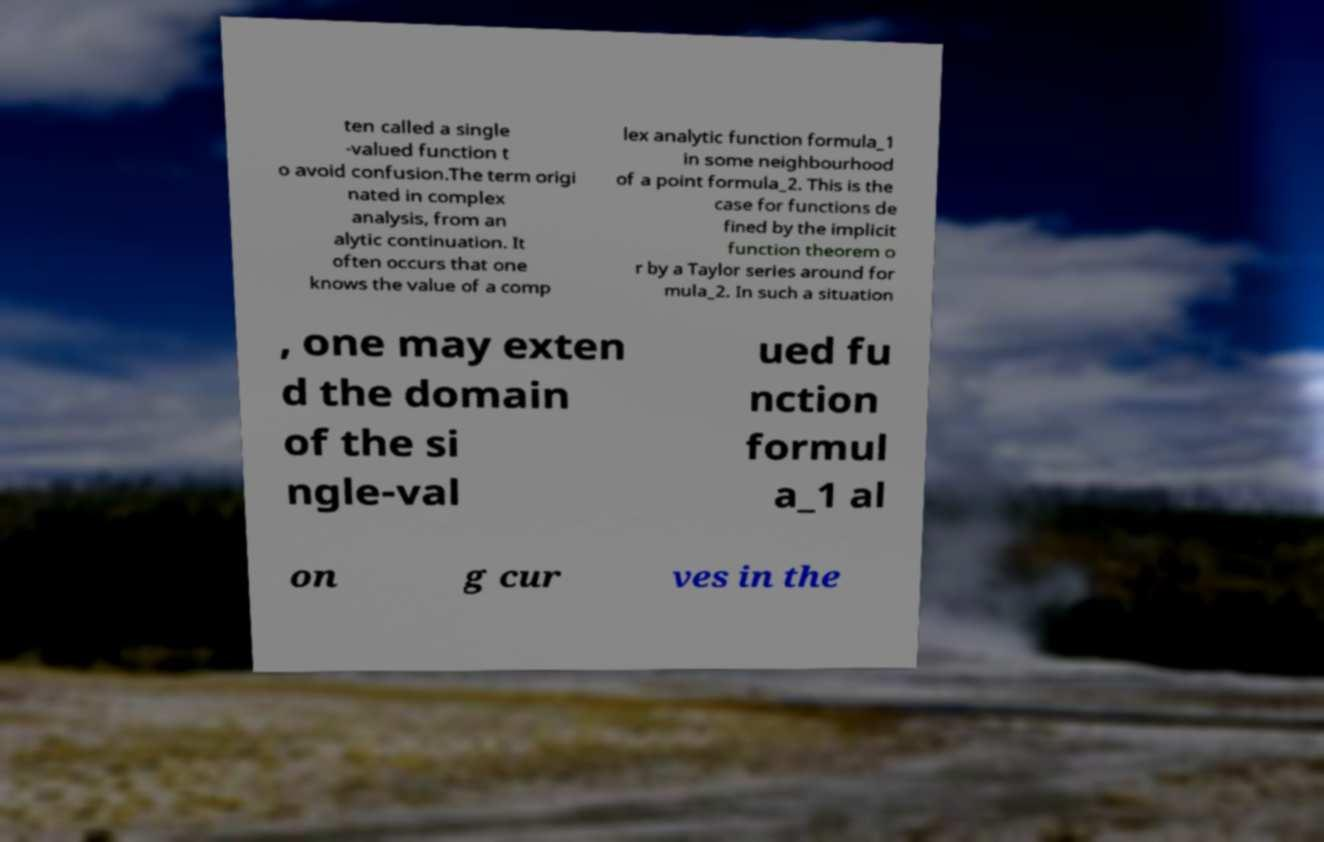For documentation purposes, I need the text within this image transcribed. Could you provide that? ten called a single -valued function t o avoid confusion.The term origi nated in complex analysis, from an alytic continuation. It often occurs that one knows the value of a comp lex analytic function formula_1 in some neighbourhood of a point formula_2. This is the case for functions de fined by the implicit function theorem o r by a Taylor series around for mula_2. In such a situation , one may exten d the domain of the si ngle-val ued fu nction formul a_1 al on g cur ves in the 